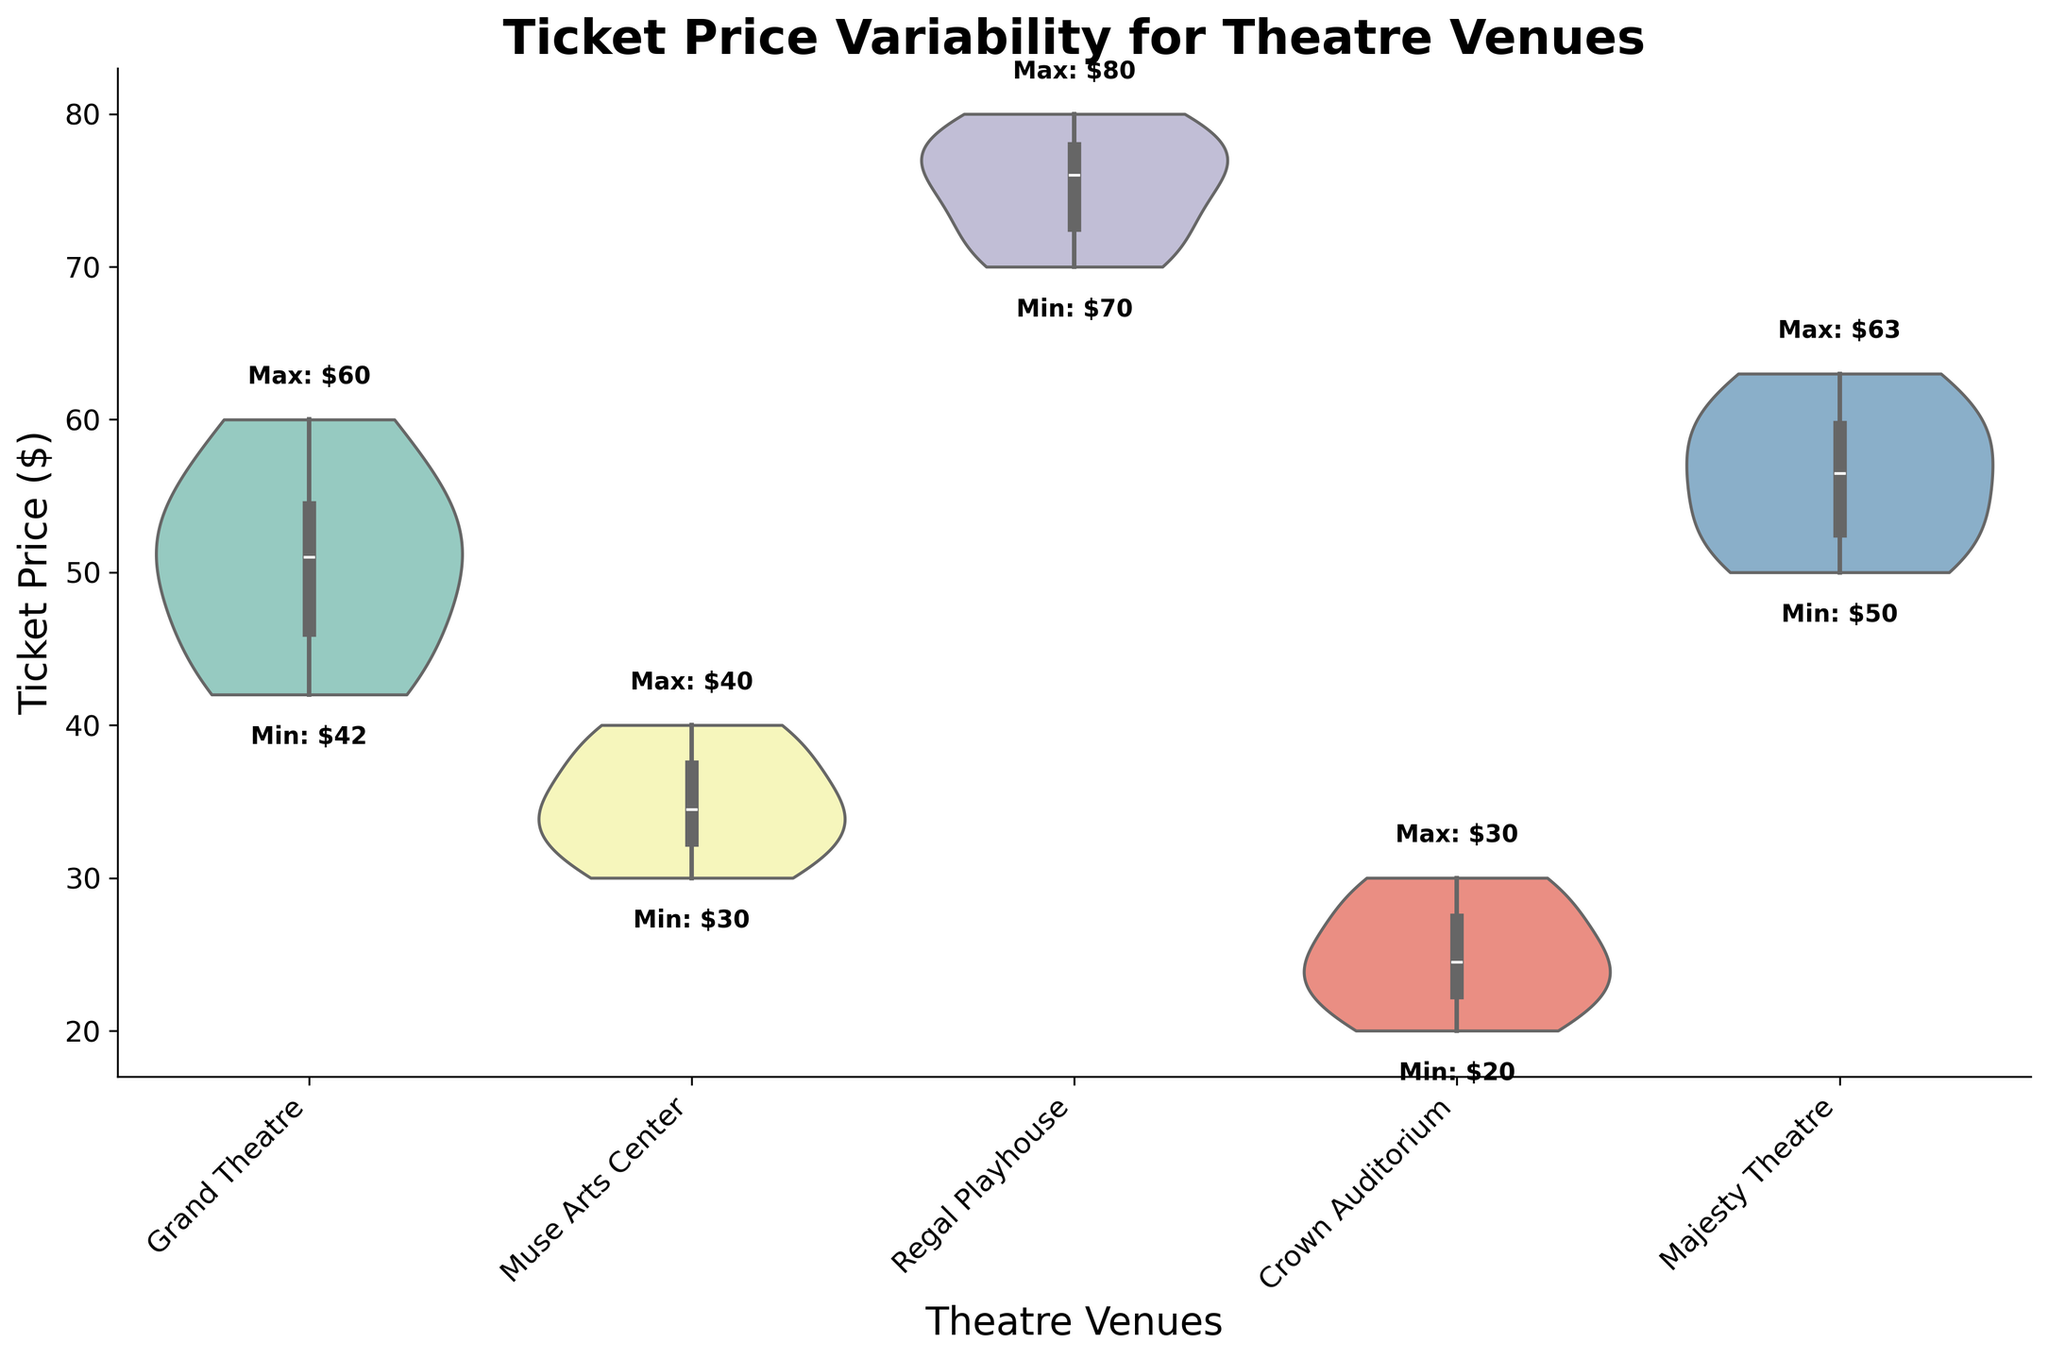What is the title of the chart? The title of the chart is displayed at the top and reads: 'Ticket Price Variability for Theatre Venues'.
Answer: Ticket Price Variability for Theatre Venues Which venue has the highest ticket price? The highest ticket price, indicated by text annotations inside the chart, belongs to the Regal Playhouse with a maximum ticket price of $80.
Answer: Regal Playhouse How much higher is the maximum ticket price for Regal Playhouse compared to Grand Theatre? The maximum ticket price for Regal Playhouse is $80, and for Grand Theatre, it is $60. The difference is calculated as $80 - $60.
Answer: $20 What is the range of ticket prices for Crown Auditorium? The minimum ticket price for Crown Auditorium is $20 and the maximum is $30. The range is calculated as $30 - $20.
Answer: $10 Aside from Regal Playhouse, which venue has the next highest maximum ticket price? The Grand Theatre has the next highest maximum ticket price after the Regal Playhouse, with a maximum of $60.
Answer: Grand Theatre How does the ticket price range of Muse Arts Center compare to Crown Auditorium? The range for Muse Arts Center is $40 - $30 = $10, and for Crown Auditorium, it is $30 - $20 = $10. Both venues have the same range of ticket prices.
Answer: same What is the median ticket price for Majesty Theatre? The ticket prices for Majesty Theatre are [50, 52, 55, 58, 60, 63]. To find the median, we need to calculate the middle value. Since there are six values, the median is the average of the 3rd and 4th values: (55 + 58) / 2.
Answer: $56.5 How do the spreads of ticket prices vary between Grand Theatre and Muse Arts Center? The Grand Theatre has a range from $42 to $60, which is $18. Muse Arts Center ranges from $30 to $40, which is $10. Hence, the spread of Grand Theatre ticket prices is larger.
Answer: Grand Theatre has a larger spread Which venue has the least variability in ticket prices? Least variability is observed from the narrowest violin plot. Crown Auditorium's plot is the narrowest and has the least variability, with ticket prices ranging from $20 to $30.
Answer: Crown Auditorium What is the visual cue used to indicate the maximum and minimum ticket prices within each venue? The visual cue used is the text annotations inside the chart, where the maximum and minimum ticket prices for each venue are annotated directly above and below the violin plots.
Answer: text annotations 